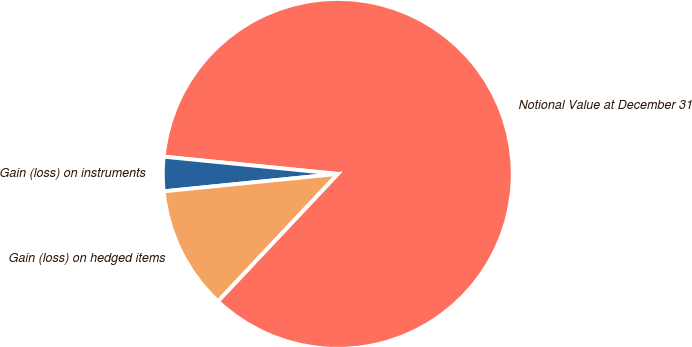Convert chart to OTSL. <chart><loc_0><loc_0><loc_500><loc_500><pie_chart><fcel>Notional Value at December 31<fcel>Gain (loss) on instruments<fcel>Gain (loss) on hedged items<nl><fcel>85.44%<fcel>3.16%<fcel>11.39%<nl></chart> 